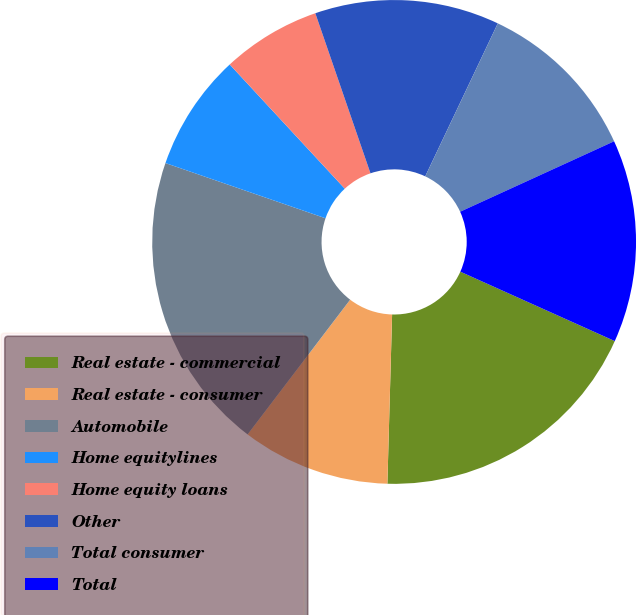Convert chart to OTSL. <chart><loc_0><loc_0><loc_500><loc_500><pie_chart><fcel>Real estate - commercial<fcel>Real estate - consumer<fcel>Automobile<fcel>Home equitylines<fcel>Home equity loans<fcel>Other<fcel>Total consumer<fcel>Total<nl><fcel>18.72%<fcel>9.91%<fcel>19.93%<fcel>7.82%<fcel>6.61%<fcel>12.33%<fcel>11.12%<fcel>13.55%<nl></chart> 